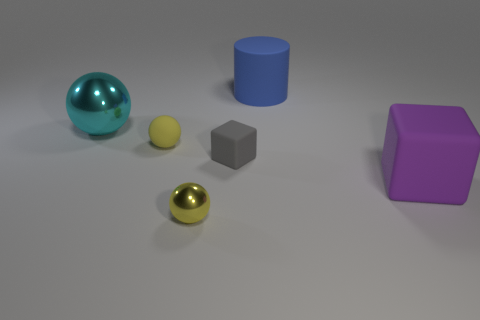Is the matte sphere the same color as the small metallic thing?
Provide a short and direct response. Yes. There is a object that is the same color as the small metal sphere; what shape is it?
Give a very brief answer. Sphere. There is a block in front of the matte cube left of the blue rubber object; what number of small gray blocks are behind it?
Your answer should be compact. 1. There is a big ball; does it have the same color as the big rubber thing left of the big block?
Provide a short and direct response. No. What number of things are yellow things behind the yellow metallic thing or yellow things behind the big block?
Offer a terse response. 1. Is the number of small cubes that are behind the tiny yellow matte ball greater than the number of large cyan balls in front of the large metal object?
Your answer should be compact. No. The yellow ball left of the ball in front of the matte thing that is in front of the tiny gray thing is made of what material?
Your answer should be compact. Rubber. There is a tiny rubber object that is in front of the rubber sphere; is it the same shape as the small yellow object behind the tiny yellow shiny ball?
Give a very brief answer. No. Are there any yellow cylinders of the same size as the gray thing?
Your response must be concise. No. What number of brown things are either tiny matte things or metallic spheres?
Keep it short and to the point. 0. 